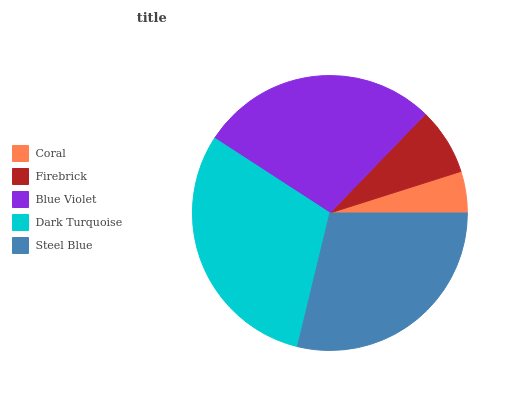Is Coral the minimum?
Answer yes or no. Yes. Is Dark Turquoise the maximum?
Answer yes or no. Yes. Is Firebrick the minimum?
Answer yes or no. No. Is Firebrick the maximum?
Answer yes or no. No. Is Firebrick greater than Coral?
Answer yes or no. Yes. Is Coral less than Firebrick?
Answer yes or no. Yes. Is Coral greater than Firebrick?
Answer yes or no. No. Is Firebrick less than Coral?
Answer yes or no. No. Is Blue Violet the high median?
Answer yes or no. Yes. Is Blue Violet the low median?
Answer yes or no. Yes. Is Steel Blue the high median?
Answer yes or no. No. Is Firebrick the low median?
Answer yes or no. No. 